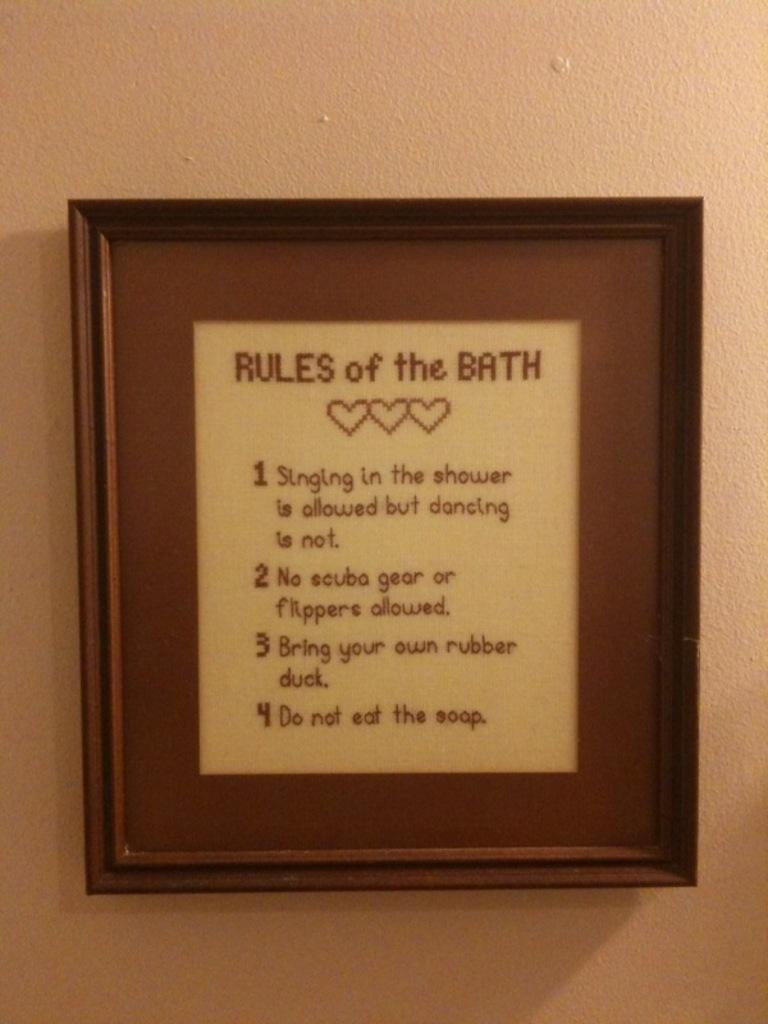<image>
Provide a brief description of the given image. A framed set of instructions titled Rules of the Bath. 